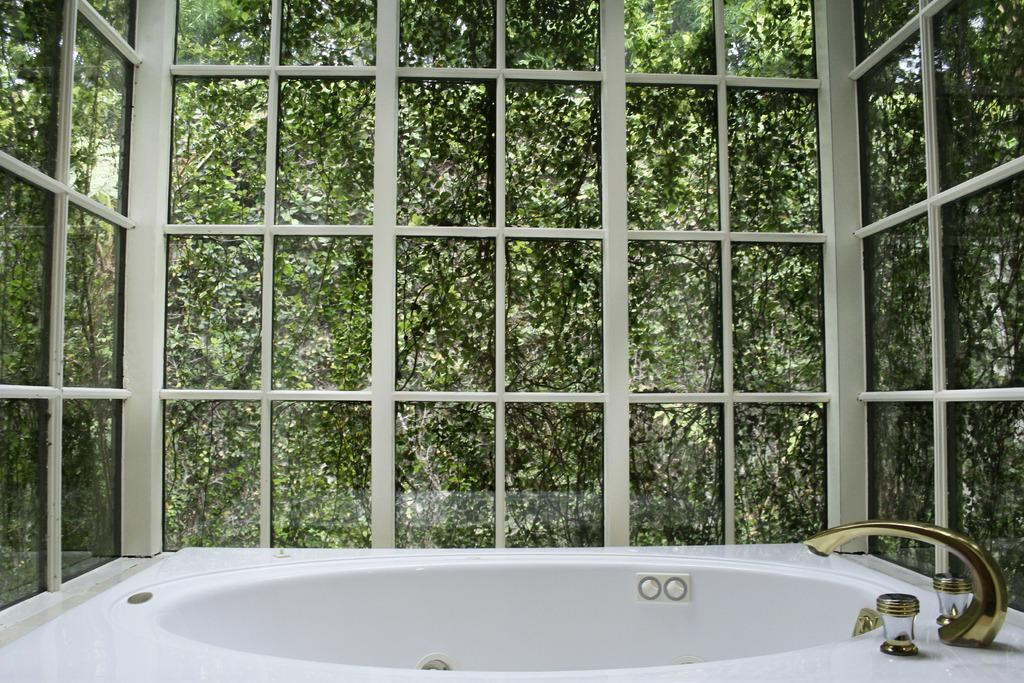What is the main object in the foreground of the image? There is a bath tub in the foreground of the image. What is located near the bath tub? There is a tap in the foreground of the image. What type of walls surround the bath tub? There are glass walls in the foreground of the image. What can be seen through the glass walls? Trees are visible through the glass walls. What type of authority figure can be seen in the middle of the image? There is no authority figure present in the image; it features a bath tub, a tap, and glass walls. What type of stem is visible in the image? There is no stem present in the image. 